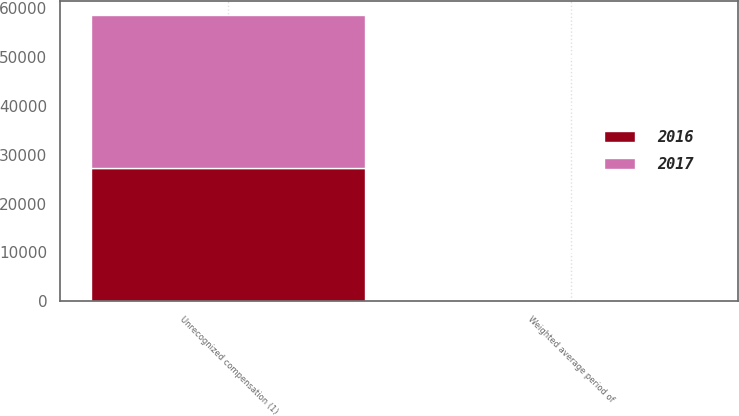Convert chart to OTSL. <chart><loc_0><loc_0><loc_500><loc_500><stacked_bar_chart><ecel><fcel>Unrecognized compensation (1)<fcel>Weighted average period of<nl><fcel>2017<fcel>31309<fcel>0.86<nl><fcel>2016<fcel>27334<fcel>0.89<nl></chart> 